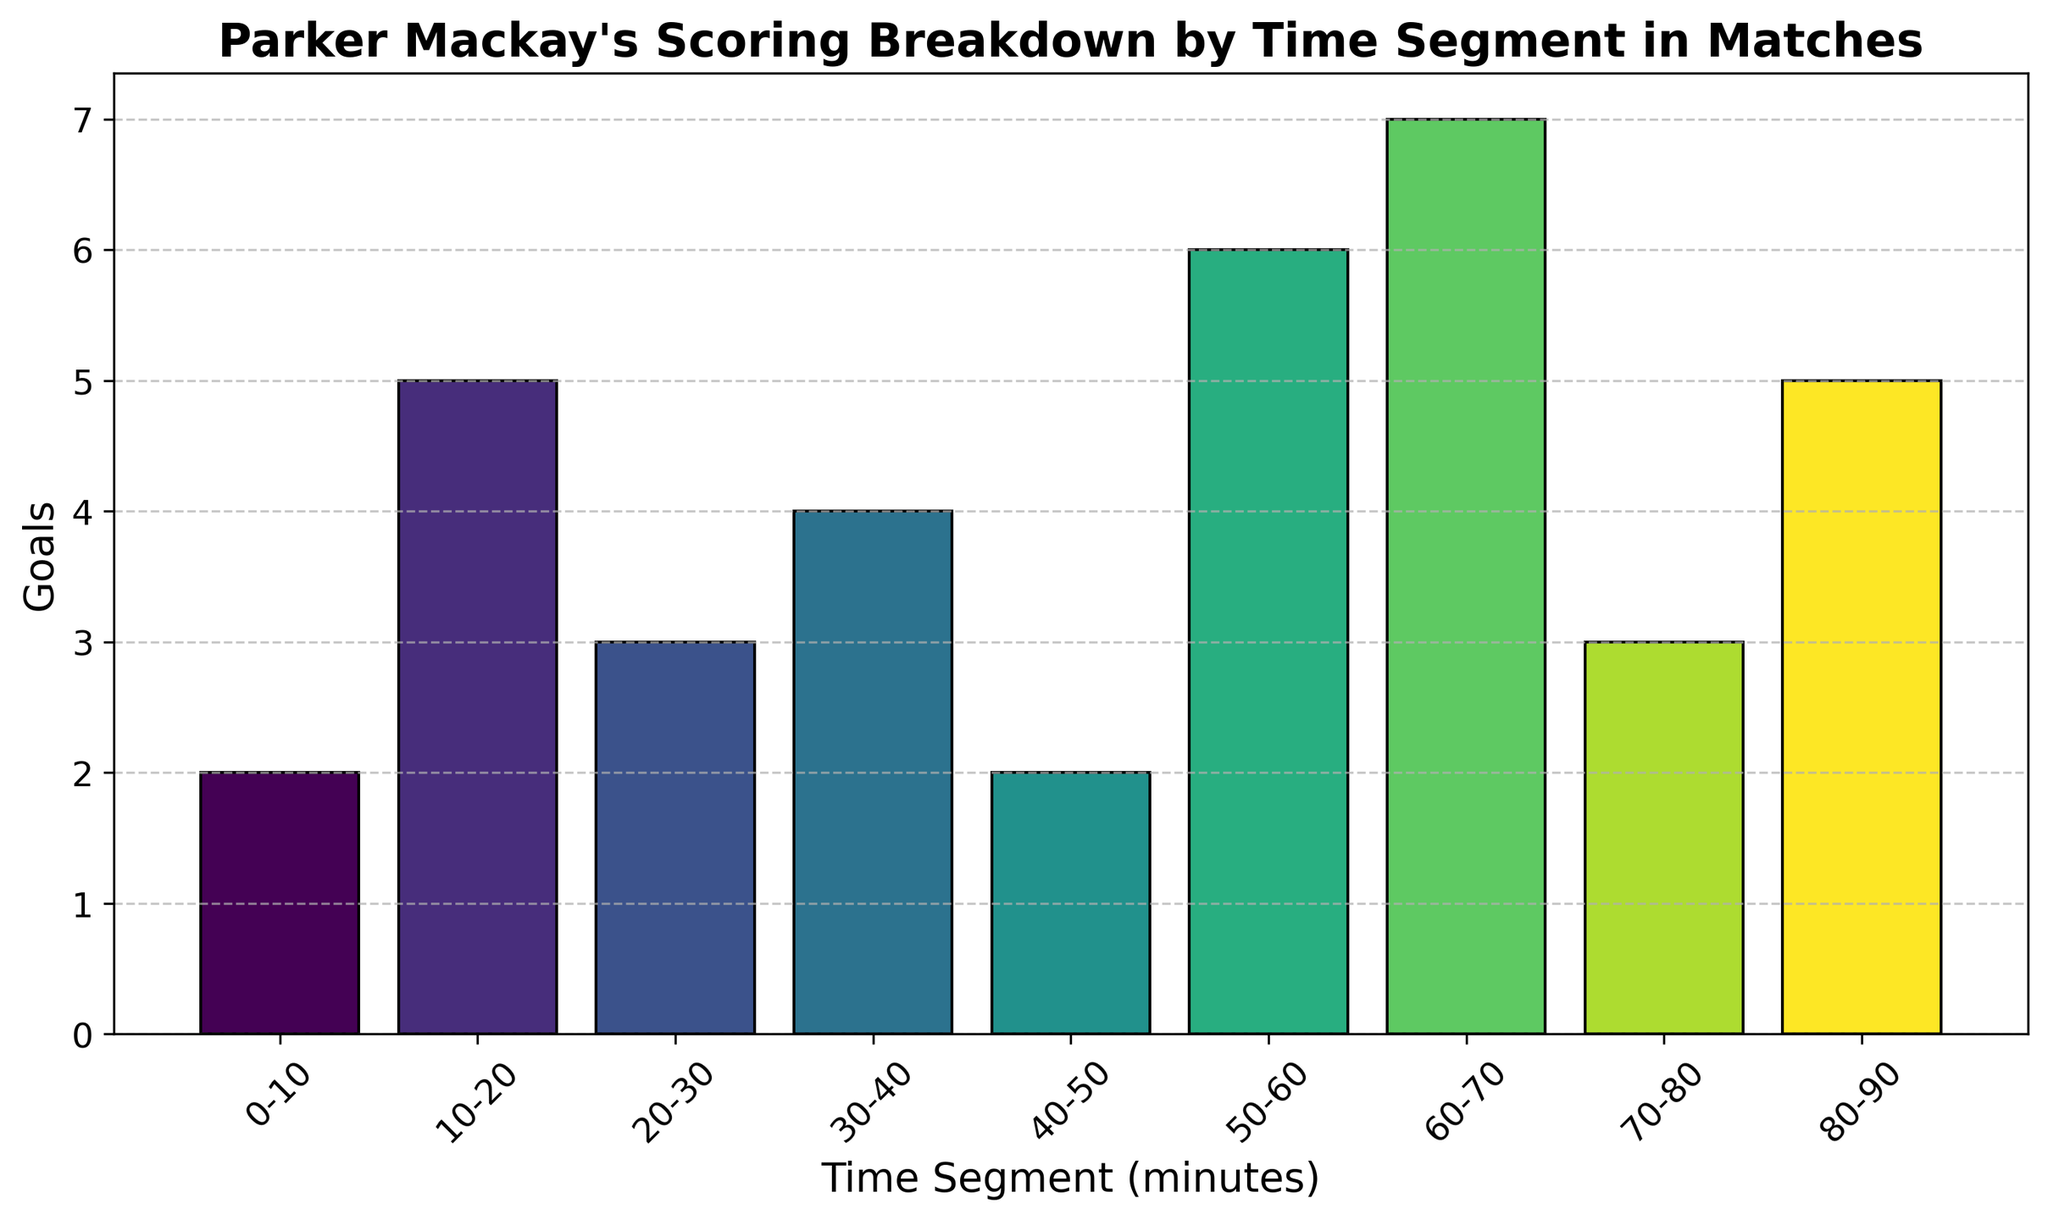What's the total number of goals scored by Parker Mackay in the 0-30 minute segments? Add the goals scored in the 0-10, 10-20, and 20-30 segments: 2 + 5 + 3 = 10
Answer: 10 Which time segment shows the highest number of goals? Look at the time segments and their corresponding goals. The 60-70 segment has the highest number of goals with 7
Answer: 60-70 Which period had fewer goals: 20-30 minutes or 70-80 minutes? Compare the goals scored in the 20-30 and 70-80 segments. 20-30 has 3 goals, and 70-80 also has 3 goals. Both periods have the same number of goals
Answer: Both are equal What's the cumulative total of goals scored from the 40-60 minute segments? Add the goals scored in the 40-50 and 50-60 segments: 2 + 6 = 8
Answer: 8 What is the average number of goals scored per segment? Total number of goals is 2 + 5 + 3 + 4 + 2 + 6 + 7 + 3 + 5 = 37. There are 9 segments, so the average is 37/9 ≈ 4.11
Answer: 4.11 During which pair of adjacent time segments did Parker Mackay score a combined total of 12 goals? Check pairs of adjacent segments: 0-10 & 10-20 (2+5=7), 10-20 & 20-30 (5+3=8), 20-30 & 30-40 (3+4=7), 30-40 & 40-50 (4+2=6), 40-50 & 50-60 (2+6=8), 50-60 & 60-70 (6+7=13), 60-70 & 70-80 (7+3=10), 70-80 & 80-90 (3+5=8). No pairs add up to 12
Answer: None Are there any segments where the number of goals scored is the same? Check each segment for the same number of goals: 0-10 and 40-50 both have 2 goals, 20-30 and 70-80 both have 3 goals
Answer: Yes How many goals did Parker Mackay score in the last 30 minutes of the match? Add the goals scored in the 60-70, 70-80, and 80-90 segments: 7 + 3 + 5 = 15
Answer: 15 